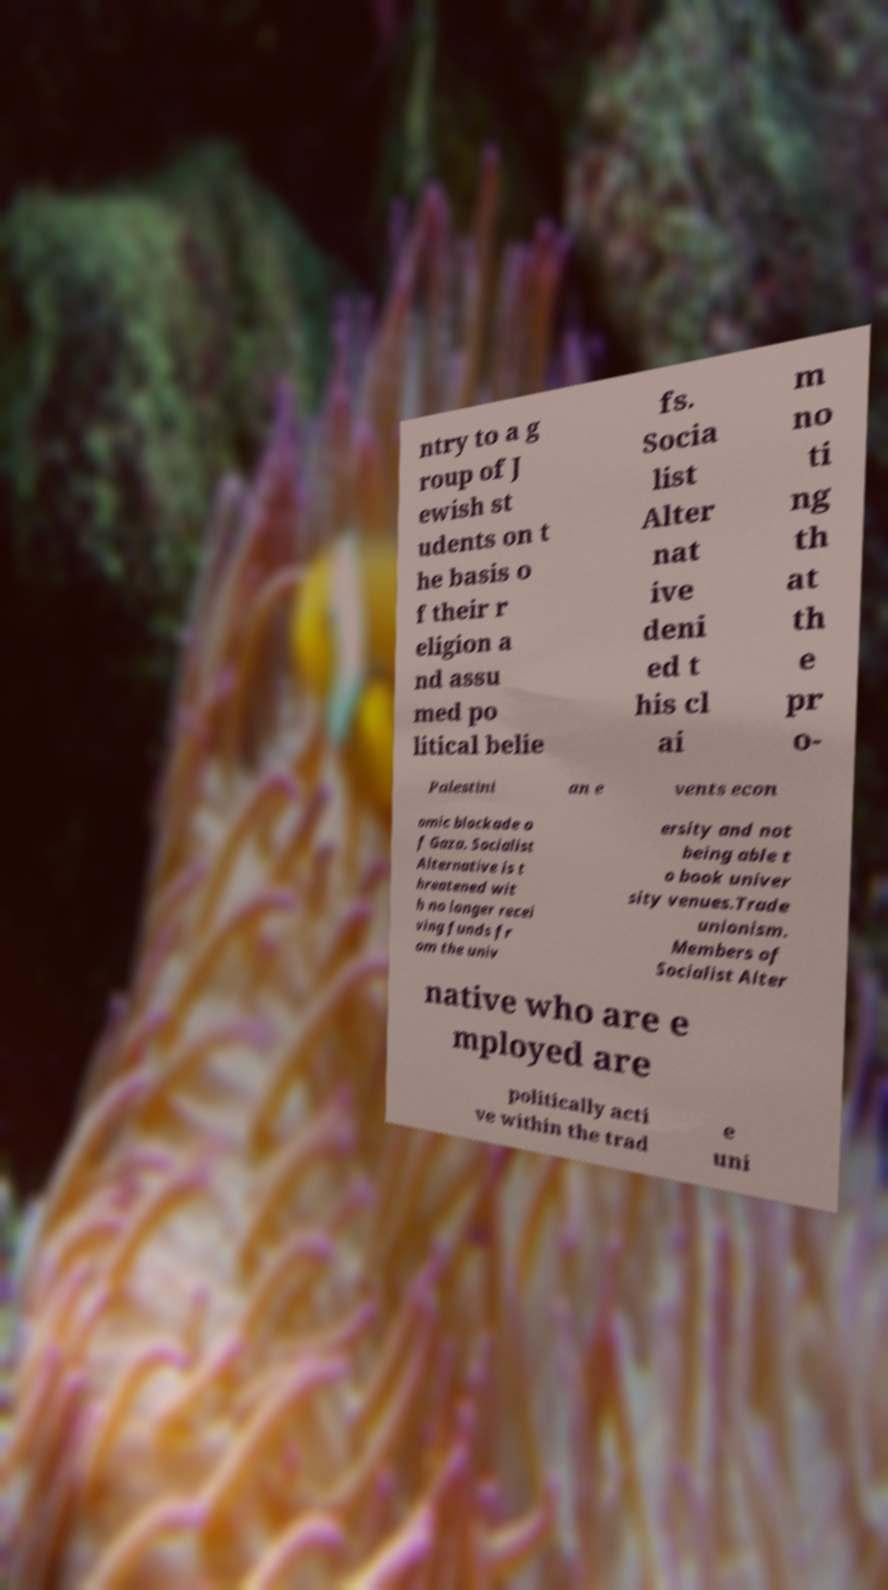Could you assist in decoding the text presented in this image and type it out clearly? ntry to a g roup of J ewish st udents on t he basis o f their r eligion a nd assu med po litical belie fs. Socia list Alter nat ive deni ed t his cl ai m no ti ng th at th e pr o- Palestini an e vents econ omic blockade o f Gaza. Socialist Alternative is t hreatened wit h no longer recei ving funds fr om the univ ersity and not being able t o book univer sity venues.Trade unionism. Members of Socialist Alter native who are e mployed are politically acti ve within the trad e uni 